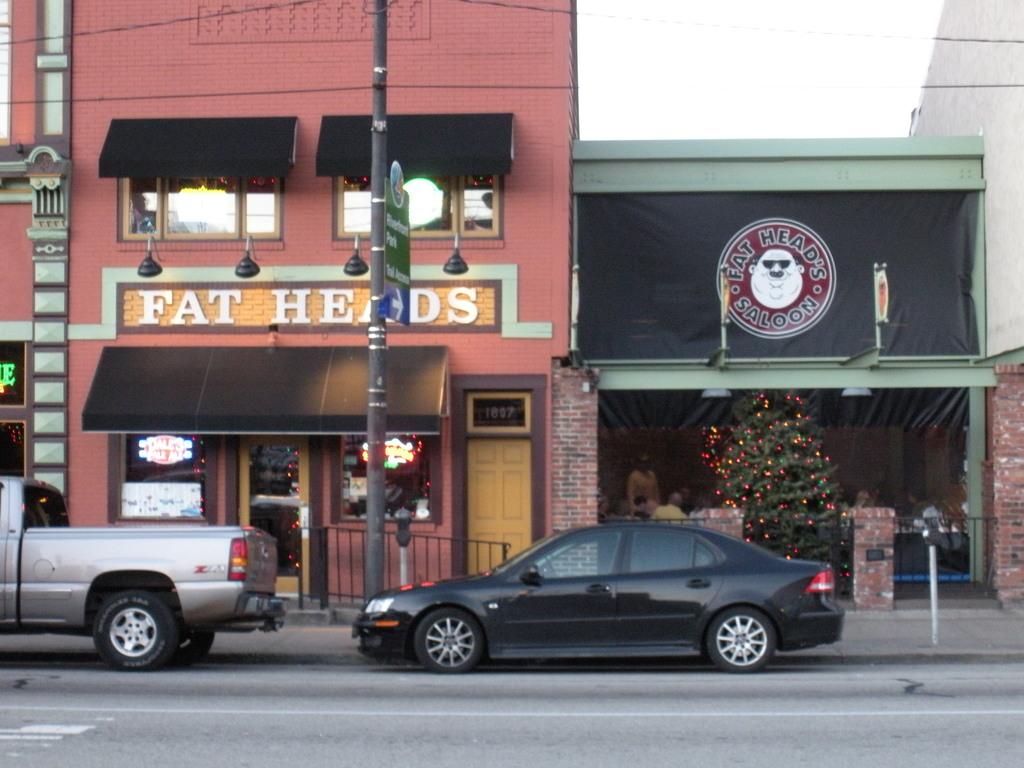What is the name of the saloon in this picture?
Provide a short and direct response. Fat heads. What is the street number of this business?
Provide a succinct answer. 1807. 